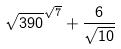<formula> <loc_0><loc_0><loc_500><loc_500>\sqrt { 3 9 0 } ^ { \sqrt { 7 } } + \frac { 6 } { \sqrt { 1 0 } }</formula> 